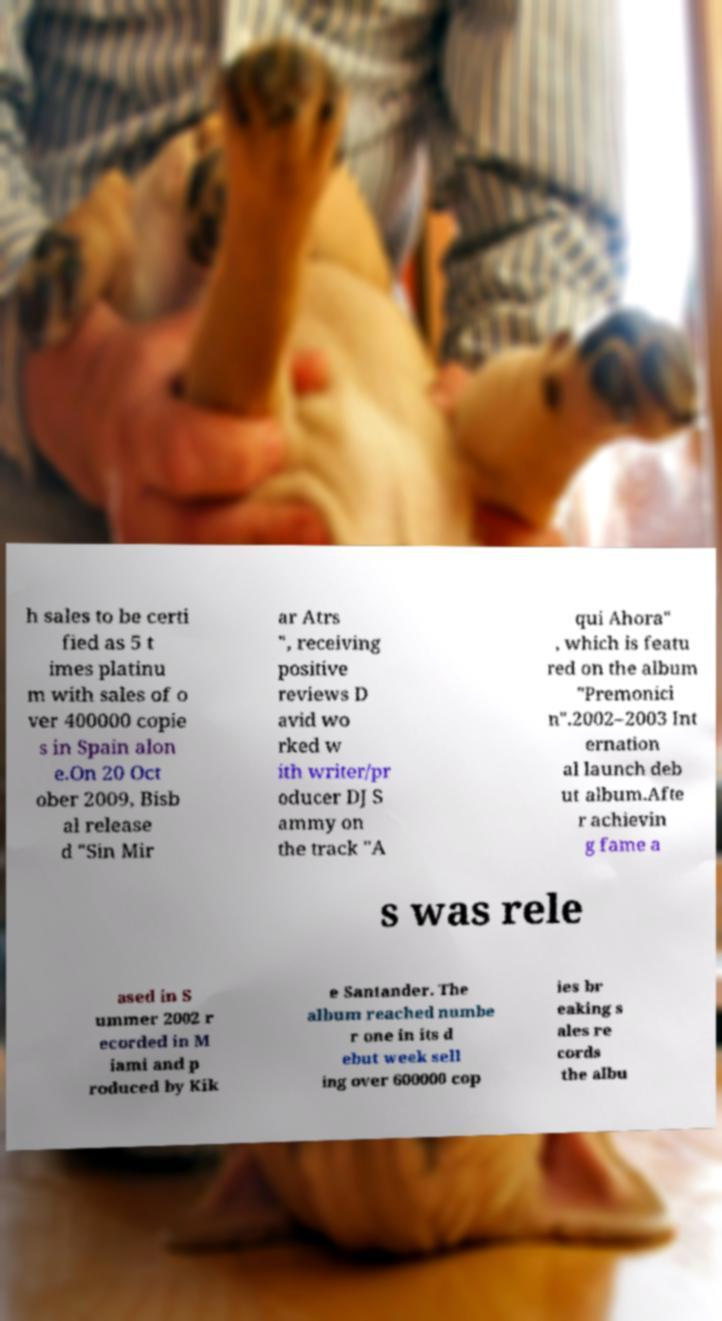What messages or text are displayed in this image? I need them in a readable, typed format. h sales to be certi fied as 5 t imes platinu m with sales of o ver 400000 copie s in Spain alon e.On 20 Oct ober 2009, Bisb al release d "Sin Mir ar Atrs ", receiving positive reviews D avid wo rked w ith writer/pr oducer DJ S ammy on the track "A qui Ahora" , which is featu red on the album "Premonici n".2002–2003 Int ernation al launch deb ut album.Afte r achievin g fame a s was rele ased in S ummer 2002 r ecorded in M iami and p roduced by Kik e Santander. The album reached numbe r one in its d ebut week sell ing over 600000 cop ies br eaking s ales re cords the albu 